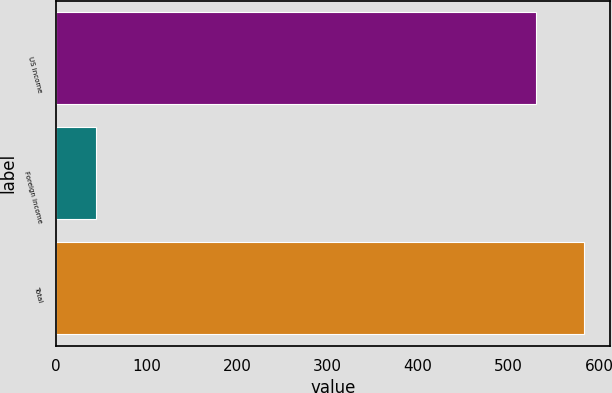<chart> <loc_0><loc_0><loc_500><loc_500><bar_chart><fcel>US income<fcel>Foreign income<fcel>Total<nl><fcel>530<fcel>44<fcel>583<nl></chart> 